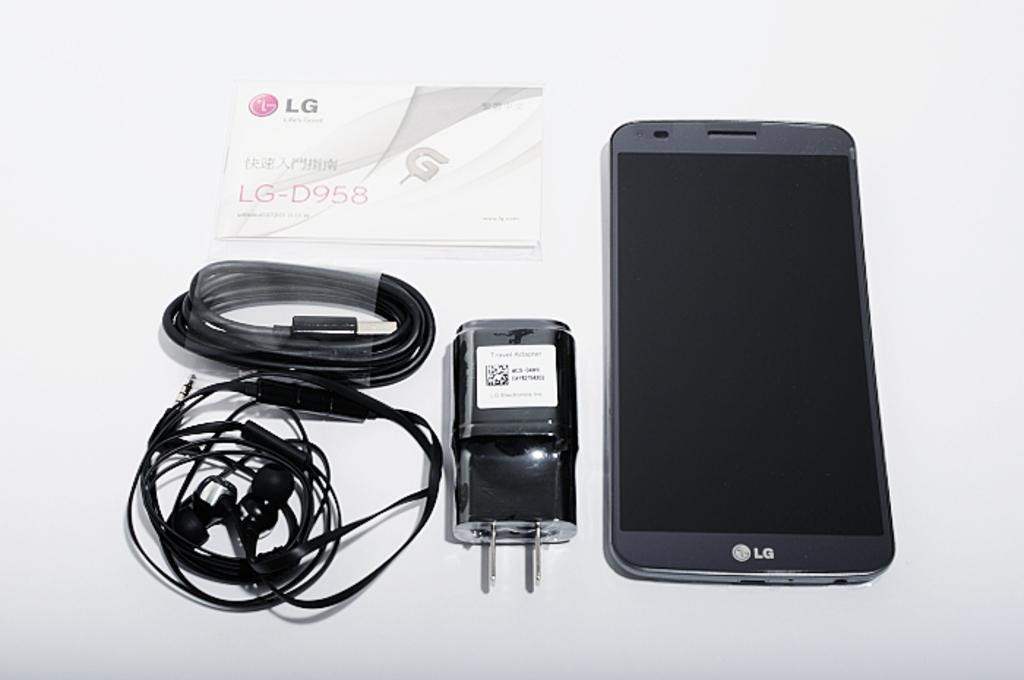<image>
Present a compact description of the photo's key features. An LG cellphone with headphones and a charging cord. 